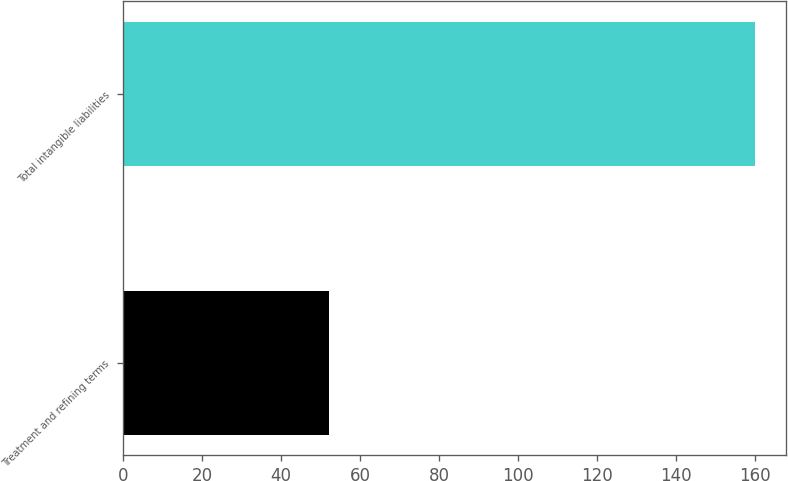Convert chart to OTSL. <chart><loc_0><loc_0><loc_500><loc_500><bar_chart><fcel>Treatment and refining terms<fcel>Total intangible liabilities<nl><fcel>52<fcel>160<nl></chart> 